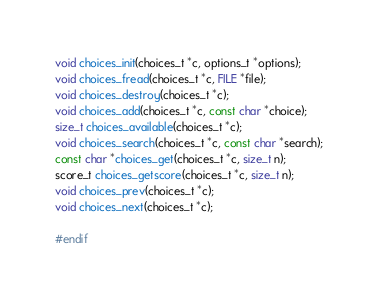<code> <loc_0><loc_0><loc_500><loc_500><_C_>
void choices_init(choices_t *c, options_t *options);
void choices_fread(choices_t *c, FILE *file);
void choices_destroy(choices_t *c);
void choices_add(choices_t *c, const char *choice);
size_t choices_available(choices_t *c);
void choices_search(choices_t *c, const char *search);
const char *choices_get(choices_t *c, size_t n);
score_t choices_getscore(choices_t *c, size_t n);
void choices_prev(choices_t *c);
void choices_next(choices_t *c);

#endif
</code> 